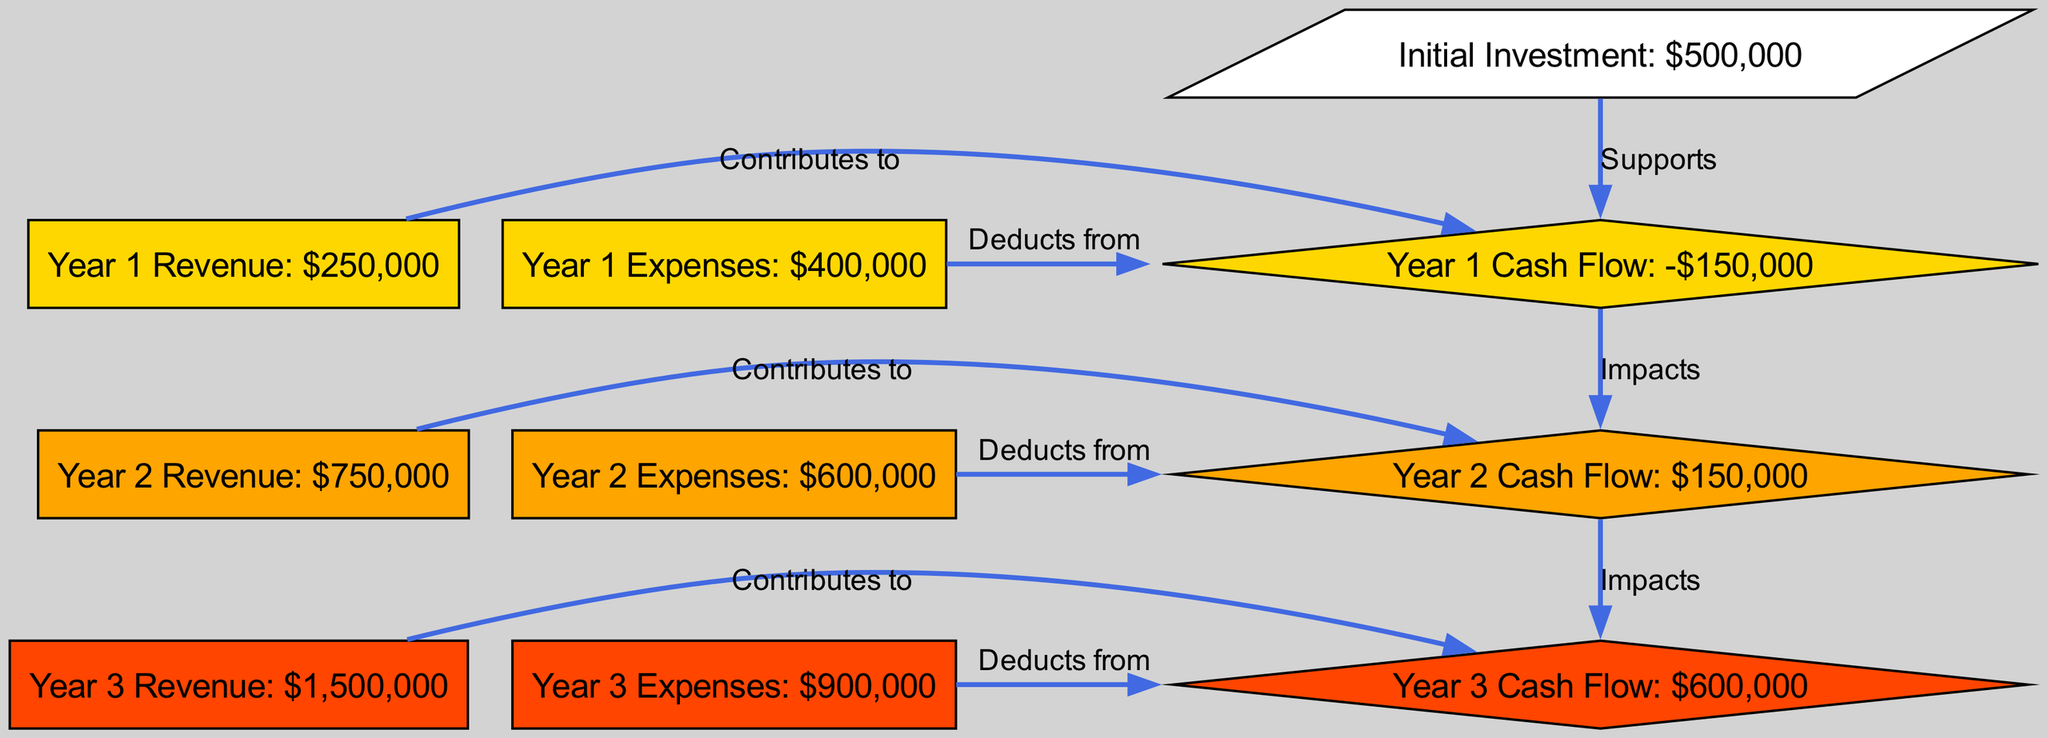What is the initial investment amount? The initial investment node is labeled with "Initial Investment: $500,000". Therefore, the amount is directly read from this node.
Answer: $500,000 What is the cash flow for Year 1? The cash flow for Year 1 is indicated in the node "Year 1 Cash Flow: -$150,000". This value is shown in the corresponding cash flow node.
Answer: -$150,000 What does Year 2 Revenue contribute to? According to the diagram, "Year 2 Revenue" contributes to "Year 2 Cash Flow". This connection is indicated with an edge labeled "Contributes to".
Answer: Year 2 Cash Flow How much are the expenses in Year 3? The expenses for Year 3 are stated in the node labeled "Year 3 Expenses: $900,000". The information is presented clearly in the diagram.
Answer: $900,000 What is the impact of Year 1 Cash Flow on Year 2 Cash Flow? The diagram shows an edge between "Year 1 Cash Flow" and "Year 2 Cash Flow" labeled "Impacts". This indicates that the cash flow from Year 1 affects the cash flow in Year 2.
Answer: Impacts What is the total revenue in Year 3? The node labeled "Year 3 Revenue: $1,500,000" indicates the amount directly. This direct information can be found in the revenue node for Year 3.
Answer: $1,500,000 What is the trend in cash flow from Year 1 to Year 3? By analyzing the cash flow values, it is observed that Year 1 has a negative cash flow, while Year 3 has a positive cash flow. This change indicates an overall positive trend from negative to positive cash flow over the years.
Answer: Positive trend How do revenues and expenses affect cash flow? The diagram illustrates the relationships where revenues contribute to cash flow while expenses deduct from cash flow for each year. This establishes a clear relationship of influence between these variables and cash flow.
Answer: Contribute and Deduct What is the substantial change observed in Year 2 Cash Flow compared to Year 1 Cash Flow? The Year 2 Cash Flow shows $150,000, which is an improvement from Year 1’s cash flow of -$150,000. This indicates a turnaround from negative to positive cash flow, marking a significant financial improvement.
Answer: Turnaround 